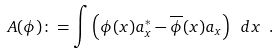Convert formula to latex. <formula><loc_0><loc_0><loc_500><loc_500>A ( \phi ) \colon = \int \left ( \phi ( x ) a ^ { \ast } _ { x } - \overline { \phi } ( x ) a _ { x } \right ) \ d x \ .</formula> 